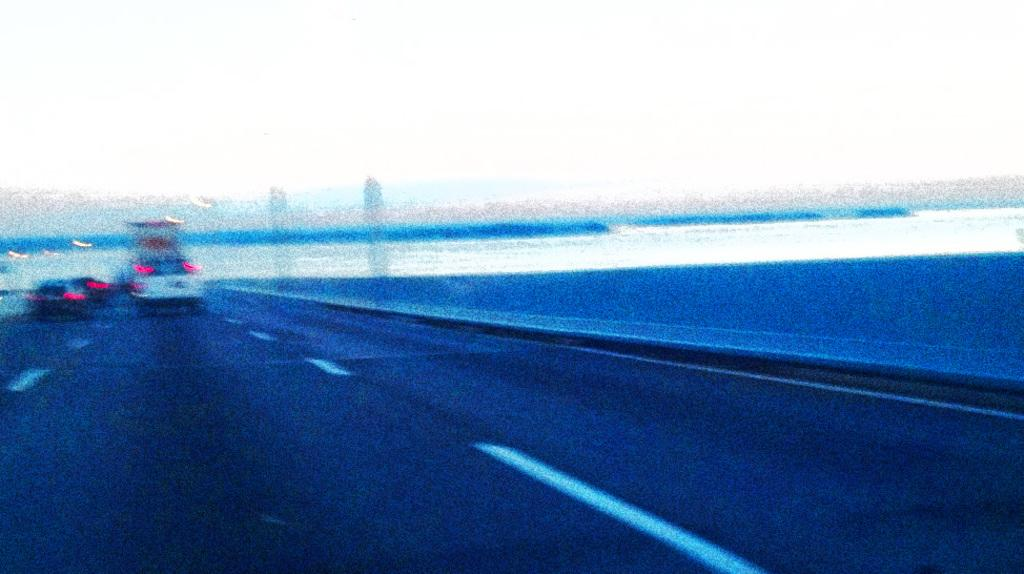What can be seen on the road in the image? There are vehicles on the road in the image. What type of cap is being worn by the record on the stitch in the image? There is no cap, record, or stitch present in the image; it only features vehicles on the road. 